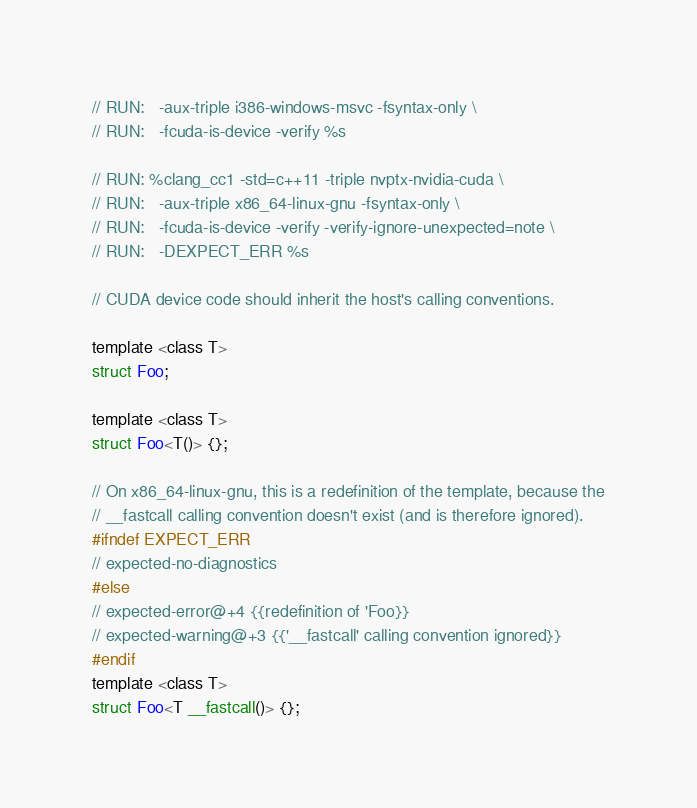Convert code to text. <code><loc_0><loc_0><loc_500><loc_500><_Cuda_>// RUN:   -aux-triple i386-windows-msvc -fsyntax-only \
// RUN:   -fcuda-is-device -verify %s

// RUN: %clang_cc1 -std=c++11 -triple nvptx-nvidia-cuda \
// RUN:   -aux-triple x86_64-linux-gnu -fsyntax-only \
// RUN:   -fcuda-is-device -verify -verify-ignore-unexpected=note \
// RUN:   -DEXPECT_ERR %s

// CUDA device code should inherit the host's calling conventions.

template <class T>
struct Foo;

template <class T>
struct Foo<T()> {};

// On x86_64-linux-gnu, this is a redefinition of the template, because the
// __fastcall calling convention doesn't exist (and is therefore ignored).
#ifndef EXPECT_ERR
// expected-no-diagnostics
#else
// expected-error@+4 {{redefinition of 'Foo}}
// expected-warning@+3 {{'__fastcall' calling convention ignored}}
#endif
template <class T>
struct Foo<T __fastcall()> {};
</code> 